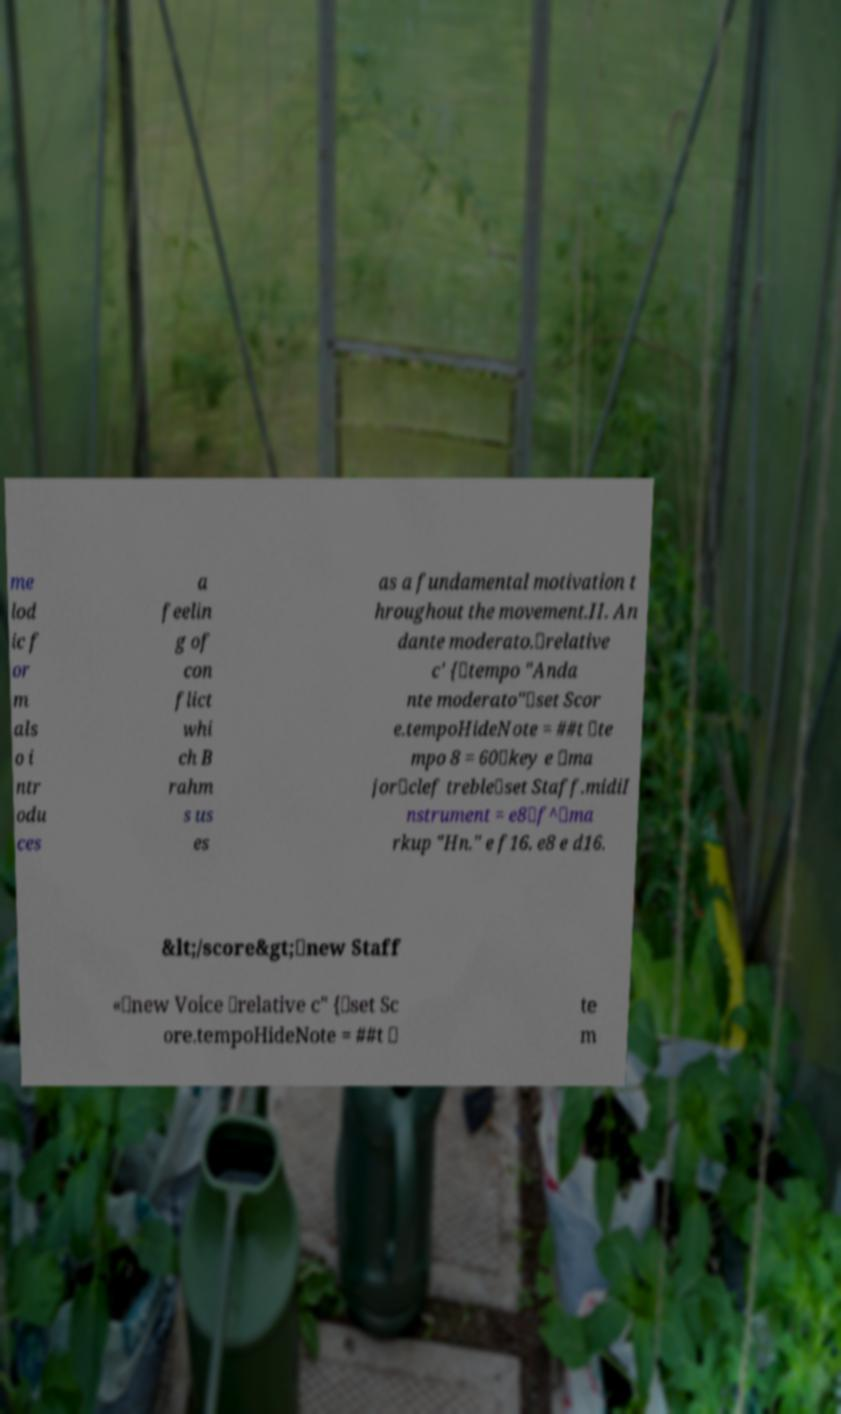Could you extract and type out the text from this image? me lod ic f or m als o i ntr odu ces a feelin g of con flict whi ch B rahm s us es as a fundamental motivation t hroughout the movement.II. An dante moderato.\relative c' {\tempo "Anda nte moderato"\set Scor e.tempoHideNote = ##t \te mpo 8 = 60\key e \ma jor\clef treble\set Staff.midiI nstrument = e8\f^\ma rkup "Hn." e f16. e8 e d16. &lt;/score&gt;\new Staff «\new Voice \relative c" {\set Sc ore.tempoHideNote = ##t \ te m 